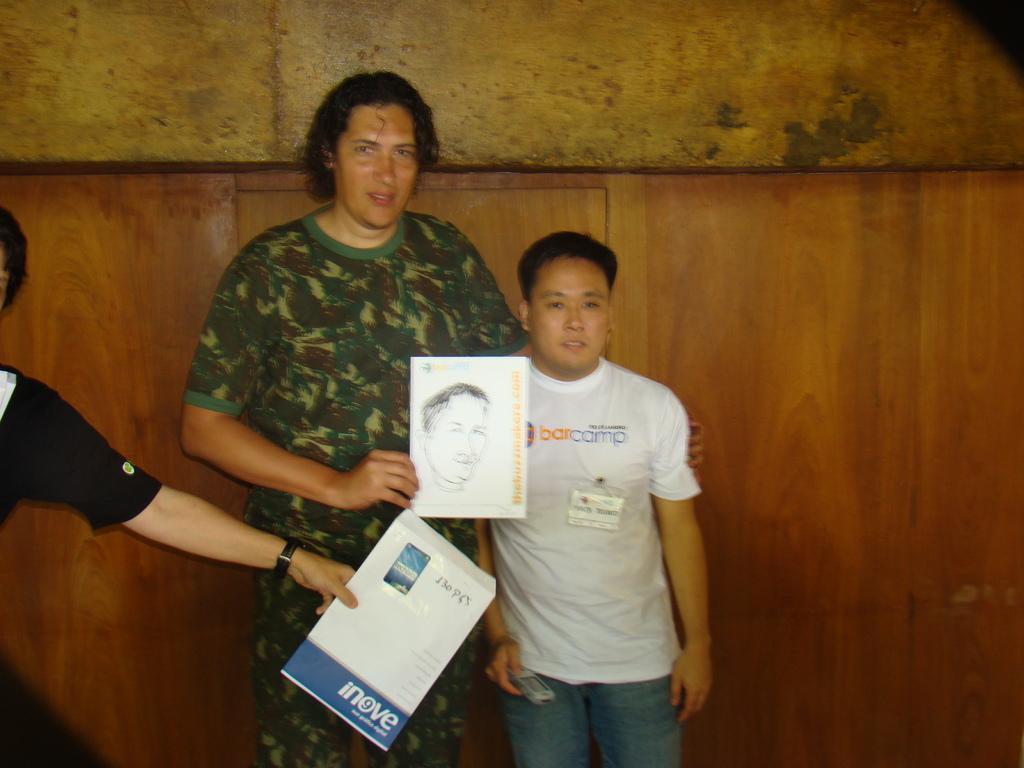In one or two sentences, can you explain what this image depicts? In this image in front there are three people holding the books. Behind them there is a wall. 